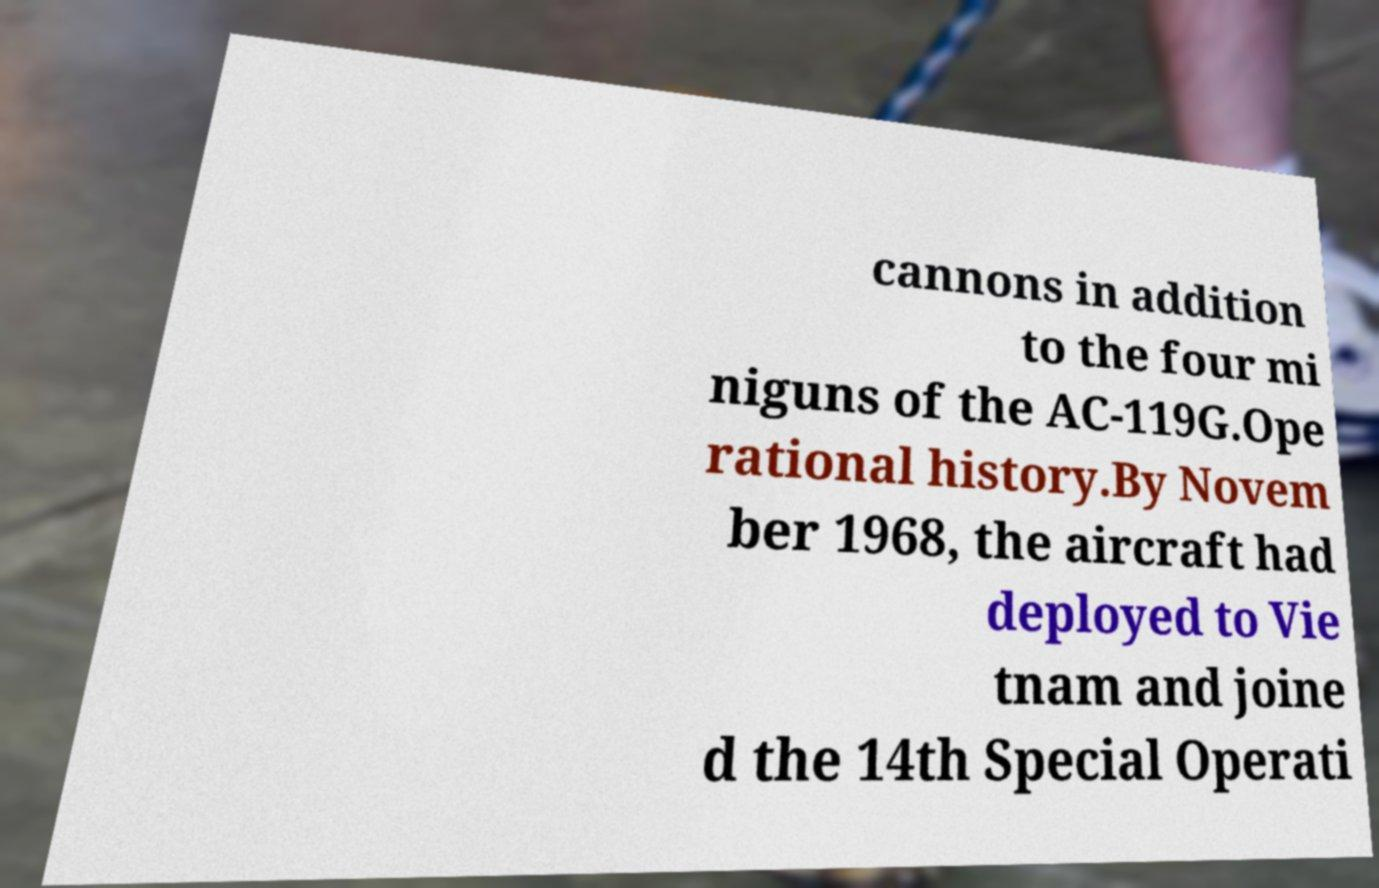For documentation purposes, I need the text within this image transcribed. Could you provide that? cannons in addition to the four mi niguns of the AC-119G.Ope rational history.By Novem ber 1968, the aircraft had deployed to Vie tnam and joine d the 14th Special Operati 